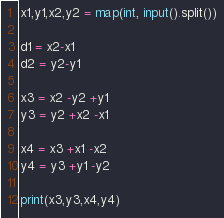Convert code to text. <code><loc_0><loc_0><loc_500><loc_500><_Python_>x1,y1,x2,y2 = map(int, input().split())

d1 = x2-x1
d2 = y2-y1

x3 = x2 -y2 +y1
y3 = y2 +x2 -x1

x4 = x3 +x1 -x2
y4 = y3 +y1 -y2

print(x3,y3,x4,y4)</code> 